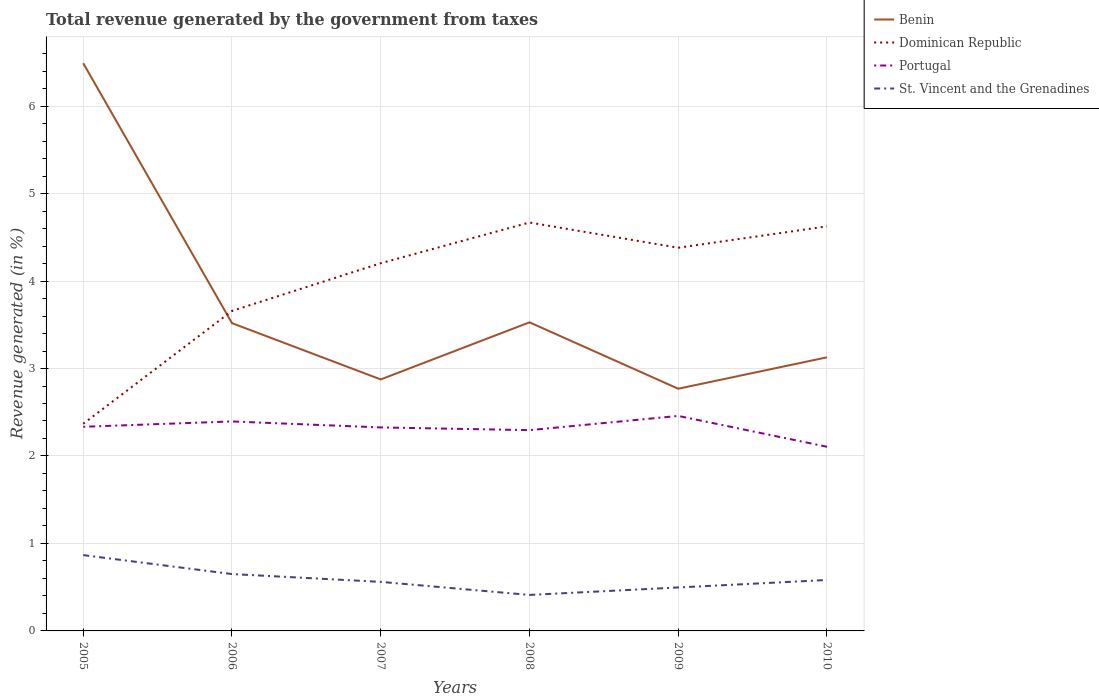How many different coloured lines are there?
Your response must be concise. 4. Does the line corresponding to St. Vincent and the Grenadines intersect with the line corresponding to Dominican Republic?
Make the answer very short. No. Across all years, what is the maximum total revenue generated in St. Vincent and the Grenadines?
Keep it short and to the point. 0.41. What is the total total revenue generated in Dominican Republic in the graph?
Give a very brief answer. 0.04. What is the difference between the highest and the second highest total revenue generated in Portugal?
Your response must be concise. 0.35. Is the total revenue generated in St. Vincent and the Grenadines strictly greater than the total revenue generated in Benin over the years?
Give a very brief answer. Yes. How many lines are there?
Provide a short and direct response. 4. What is the difference between two consecutive major ticks on the Y-axis?
Keep it short and to the point. 1. Does the graph contain any zero values?
Your answer should be compact. No. Does the graph contain grids?
Ensure brevity in your answer.  Yes. Where does the legend appear in the graph?
Make the answer very short. Top right. How are the legend labels stacked?
Provide a succinct answer. Vertical. What is the title of the graph?
Provide a short and direct response. Total revenue generated by the government from taxes. What is the label or title of the Y-axis?
Provide a succinct answer. Revenue generated (in %). What is the Revenue generated (in %) of Benin in 2005?
Your answer should be very brief. 6.49. What is the Revenue generated (in %) in Dominican Republic in 2005?
Your response must be concise. 2.37. What is the Revenue generated (in %) of Portugal in 2005?
Ensure brevity in your answer.  2.33. What is the Revenue generated (in %) in St. Vincent and the Grenadines in 2005?
Your response must be concise. 0.87. What is the Revenue generated (in %) in Benin in 2006?
Provide a succinct answer. 3.52. What is the Revenue generated (in %) in Dominican Republic in 2006?
Keep it short and to the point. 3.66. What is the Revenue generated (in %) of Portugal in 2006?
Your answer should be compact. 2.39. What is the Revenue generated (in %) of St. Vincent and the Grenadines in 2006?
Offer a very short reply. 0.65. What is the Revenue generated (in %) of Benin in 2007?
Keep it short and to the point. 2.88. What is the Revenue generated (in %) of Dominican Republic in 2007?
Your answer should be very brief. 4.2. What is the Revenue generated (in %) of Portugal in 2007?
Provide a short and direct response. 2.33. What is the Revenue generated (in %) of St. Vincent and the Grenadines in 2007?
Your answer should be compact. 0.56. What is the Revenue generated (in %) of Benin in 2008?
Your response must be concise. 3.53. What is the Revenue generated (in %) in Dominican Republic in 2008?
Keep it short and to the point. 4.67. What is the Revenue generated (in %) of Portugal in 2008?
Keep it short and to the point. 2.3. What is the Revenue generated (in %) of St. Vincent and the Grenadines in 2008?
Give a very brief answer. 0.41. What is the Revenue generated (in %) of Benin in 2009?
Give a very brief answer. 2.77. What is the Revenue generated (in %) in Dominican Republic in 2009?
Provide a succinct answer. 4.38. What is the Revenue generated (in %) of Portugal in 2009?
Make the answer very short. 2.46. What is the Revenue generated (in %) of St. Vincent and the Grenadines in 2009?
Provide a succinct answer. 0.5. What is the Revenue generated (in %) in Benin in 2010?
Give a very brief answer. 3.13. What is the Revenue generated (in %) of Dominican Republic in 2010?
Keep it short and to the point. 4.63. What is the Revenue generated (in %) in Portugal in 2010?
Give a very brief answer. 2.11. What is the Revenue generated (in %) of St. Vincent and the Grenadines in 2010?
Offer a very short reply. 0.58. Across all years, what is the maximum Revenue generated (in %) in Benin?
Your response must be concise. 6.49. Across all years, what is the maximum Revenue generated (in %) of Dominican Republic?
Make the answer very short. 4.67. Across all years, what is the maximum Revenue generated (in %) in Portugal?
Your response must be concise. 2.46. Across all years, what is the maximum Revenue generated (in %) of St. Vincent and the Grenadines?
Ensure brevity in your answer.  0.87. Across all years, what is the minimum Revenue generated (in %) in Benin?
Offer a terse response. 2.77. Across all years, what is the minimum Revenue generated (in %) in Dominican Republic?
Give a very brief answer. 2.37. Across all years, what is the minimum Revenue generated (in %) of Portugal?
Make the answer very short. 2.11. Across all years, what is the minimum Revenue generated (in %) in St. Vincent and the Grenadines?
Give a very brief answer. 0.41. What is the total Revenue generated (in %) in Benin in the graph?
Your response must be concise. 22.31. What is the total Revenue generated (in %) in Dominican Republic in the graph?
Ensure brevity in your answer.  23.91. What is the total Revenue generated (in %) in Portugal in the graph?
Your answer should be compact. 13.91. What is the total Revenue generated (in %) in St. Vincent and the Grenadines in the graph?
Provide a short and direct response. 3.57. What is the difference between the Revenue generated (in %) in Benin in 2005 and that in 2006?
Keep it short and to the point. 2.97. What is the difference between the Revenue generated (in %) of Dominican Republic in 2005 and that in 2006?
Ensure brevity in your answer.  -1.29. What is the difference between the Revenue generated (in %) in Portugal in 2005 and that in 2006?
Make the answer very short. -0.06. What is the difference between the Revenue generated (in %) of St. Vincent and the Grenadines in 2005 and that in 2006?
Offer a terse response. 0.22. What is the difference between the Revenue generated (in %) of Benin in 2005 and that in 2007?
Make the answer very short. 3.62. What is the difference between the Revenue generated (in %) of Dominican Republic in 2005 and that in 2007?
Ensure brevity in your answer.  -1.84. What is the difference between the Revenue generated (in %) in Portugal in 2005 and that in 2007?
Ensure brevity in your answer.  0.01. What is the difference between the Revenue generated (in %) of St. Vincent and the Grenadines in 2005 and that in 2007?
Your response must be concise. 0.31. What is the difference between the Revenue generated (in %) of Benin in 2005 and that in 2008?
Provide a succinct answer. 2.96. What is the difference between the Revenue generated (in %) in Dominican Republic in 2005 and that in 2008?
Make the answer very short. -2.3. What is the difference between the Revenue generated (in %) in Portugal in 2005 and that in 2008?
Your answer should be compact. 0.04. What is the difference between the Revenue generated (in %) in St. Vincent and the Grenadines in 2005 and that in 2008?
Your answer should be very brief. 0.46. What is the difference between the Revenue generated (in %) in Benin in 2005 and that in 2009?
Keep it short and to the point. 3.72. What is the difference between the Revenue generated (in %) in Dominican Republic in 2005 and that in 2009?
Provide a short and direct response. -2.01. What is the difference between the Revenue generated (in %) of Portugal in 2005 and that in 2009?
Offer a very short reply. -0.12. What is the difference between the Revenue generated (in %) in St. Vincent and the Grenadines in 2005 and that in 2009?
Make the answer very short. 0.37. What is the difference between the Revenue generated (in %) in Benin in 2005 and that in 2010?
Provide a short and direct response. 3.36. What is the difference between the Revenue generated (in %) of Dominican Republic in 2005 and that in 2010?
Keep it short and to the point. -2.26. What is the difference between the Revenue generated (in %) in Portugal in 2005 and that in 2010?
Provide a succinct answer. 0.23. What is the difference between the Revenue generated (in %) of St. Vincent and the Grenadines in 2005 and that in 2010?
Provide a succinct answer. 0.28. What is the difference between the Revenue generated (in %) in Benin in 2006 and that in 2007?
Give a very brief answer. 0.64. What is the difference between the Revenue generated (in %) of Dominican Republic in 2006 and that in 2007?
Keep it short and to the point. -0.55. What is the difference between the Revenue generated (in %) in Portugal in 2006 and that in 2007?
Give a very brief answer. 0.07. What is the difference between the Revenue generated (in %) in St. Vincent and the Grenadines in 2006 and that in 2007?
Your answer should be very brief. 0.09. What is the difference between the Revenue generated (in %) of Benin in 2006 and that in 2008?
Your response must be concise. -0.01. What is the difference between the Revenue generated (in %) of Dominican Republic in 2006 and that in 2008?
Give a very brief answer. -1.01. What is the difference between the Revenue generated (in %) in Portugal in 2006 and that in 2008?
Make the answer very short. 0.1. What is the difference between the Revenue generated (in %) of St. Vincent and the Grenadines in 2006 and that in 2008?
Your answer should be very brief. 0.24. What is the difference between the Revenue generated (in %) of Dominican Republic in 2006 and that in 2009?
Provide a short and direct response. -0.72. What is the difference between the Revenue generated (in %) in Portugal in 2006 and that in 2009?
Give a very brief answer. -0.06. What is the difference between the Revenue generated (in %) in St. Vincent and the Grenadines in 2006 and that in 2009?
Give a very brief answer. 0.15. What is the difference between the Revenue generated (in %) in Benin in 2006 and that in 2010?
Give a very brief answer. 0.39. What is the difference between the Revenue generated (in %) in Dominican Republic in 2006 and that in 2010?
Offer a very short reply. -0.97. What is the difference between the Revenue generated (in %) of Portugal in 2006 and that in 2010?
Offer a terse response. 0.29. What is the difference between the Revenue generated (in %) of St. Vincent and the Grenadines in 2006 and that in 2010?
Your response must be concise. 0.07. What is the difference between the Revenue generated (in %) in Benin in 2007 and that in 2008?
Give a very brief answer. -0.65. What is the difference between the Revenue generated (in %) in Dominican Republic in 2007 and that in 2008?
Keep it short and to the point. -0.47. What is the difference between the Revenue generated (in %) of Portugal in 2007 and that in 2008?
Provide a short and direct response. 0.03. What is the difference between the Revenue generated (in %) of St. Vincent and the Grenadines in 2007 and that in 2008?
Give a very brief answer. 0.15. What is the difference between the Revenue generated (in %) in Benin in 2007 and that in 2009?
Make the answer very short. 0.11. What is the difference between the Revenue generated (in %) in Dominican Republic in 2007 and that in 2009?
Provide a short and direct response. -0.18. What is the difference between the Revenue generated (in %) of Portugal in 2007 and that in 2009?
Give a very brief answer. -0.13. What is the difference between the Revenue generated (in %) in St. Vincent and the Grenadines in 2007 and that in 2009?
Ensure brevity in your answer.  0.06. What is the difference between the Revenue generated (in %) of Benin in 2007 and that in 2010?
Offer a very short reply. -0.25. What is the difference between the Revenue generated (in %) of Dominican Republic in 2007 and that in 2010?
Your answer should be very brief. -0.42. What is the difference between the Revenue generated (in %) in Portugal in 2007 and that in 2010?
Provide a succinct answer. 0.22. What is the difference between the Revenue generated (in %) of St. Vincent and the Grenadines in 2007 and that in 2010?
Make the answer very short. -0.02. What is the difference between the Revenue generated (in %) of Benin in 2008 and that in 2009?
Provide a succinct answer. 0.76. What is the difference between the Revenue generated (in %) of Dominican Republic in 2008 and that in 2009?
Offer a very short reply. 0.29. What is the difference between the Revenue generated (in %) in Portugal in 2008 and that in 2009?
Provide a short and direct response. -0.16. What is the difference between the Revenue generated (in %) in St. Vincent and the Grenadines in 2008 and that in 2009?
Provide a short and direct response. -0.09. What is the difference between the Revenue generated (in %) of Benin in 2008 and that in 2010?
Keep it short and to the point. 0.4. What is the difference between the Revenue generated (in %) of Dominican Republic in 2008 and that in 2010?
Provide a succinct answer. 0.04. What is the difference between the Revenue generated (in %) in Portugal in 2008 and that in 2010?
Provide a succinct answer. 0.19. What is the difference between the Revenue generated (in %) in St. Vincent and the Grenadines in 2008 and that in 2010?
Offer a terse response. -0.17. What is the difference between the Revenue generated (in %) in Benin in 2009 and that in 2010?
Provide a succinct answer. -0.36. What is the difference between the Revenue generated (in %) of Dominican Republic in 2009 and that in 2010?
Provide a short and direct response. -0.24. What is the difference between the Revenue generated (in %) of Portugal in 2009 and that in 2010?
Offer a terse response. 0.35. What is the difference between the Revenue generated (in %) of St. Vincent and the Grenadines in 2009 and that in 2010?
Your answer should be very brief. -0.09. What is the difference between the Revenue generated (in %) of Benin in 2005 and the Revenue generated (in %) of Dominican Republic in 2006?
Keep it short and to the point. 2.83. What is the difference between the Revenue generated (in %) in Benin in 2005 and the Revenue generated (in %) in Portugal in 2006?
Ensure brevity in your answer.  4.1. What is the difference between the Revenue generated (in %) of Benin in 2005 and the Revenue generated (in %) of St. Vincent and the Grenadines in 2006?
Keep it short and to the point. 5.84. What is the difference between the Revenue generated (in %) of Dominican Republic in 2005 and the Revenue generated (in %) of Portugal in 2006?
Provide a short and direct response. -0.03. What is the difference between the Revenue generated (in %) in Dominican Republic in 2005 and the Revenue generated (in %) in St. Vincent and the Grenadines in 2006?
Your answer should be very brief. 1.72. What is the difference between the Revenue generated (in %) in Portugal in 2005 and the Revenue generated (in %) in St. Vincent and the Grenadines in 2006?
Offer a very short reply. 1.68. What is the difference between the Revenue generated (in %) in Benin in 2005 and the Revenue generated (in %) in Dominican Republic in 2007?
Provide a short and direct response. 2.29. What is the difference between the Revenue generated (in %) in Benin in 2005 and the Revenue generated (in %) in Portugal in 2007?
Your answer should be very brief. 4.16. What is the difference between the Revenue generated (in %) of Benin in 2005 and the Revenue generated (in %) of St. Vincent and the Grenadines in 2007?
Give a very brief answer. 5.93. What is the difference between the Revenue generated (in %) in Dominican Republic in 2005 and the Revenue generated (in %) in Portugal in 2007?
Your response must be concise. 0.04. What is the difference between the Revenue generated (in %) of Dominican Republic in 2005 and the Revenue generated (in %) of St. Vincent and the Grenadines in 2007?
Ensure brevity in your answer.  1.81. What is the difference between the Revenue generated (in %) of Portugal in 2005 and the Revenue generated (in %) of St. Vincent and the Grenadines in 2007?
Offer a very short reply. 1.77. What is the difference between the Revenue generated (in %) in Benin in 2005 and the Revenue generated (in %) in Dominican Republic in 2008?
Provide a short and direct response. 1.82. What is the difference between the Revenue generated (in %) in Benin in 2005 and the Revenue generated (in %) in Portugal in 2008?
Your response must be concise. 4.2. What is the difference between the Revenue generated (in %) of Benin in 2005 and the Revenue generated (in %) of St. Vincent and the Grenadines in 2008?
Provide a short and direct response. 6.08. What is the difference between the Revenue generated (in %) of Dominican Republic in 2005 and the Revenue generated (in %) of Portugal in 2008?
Your response must be concise. 0.07. What is the difference between the Revenue generated (in %) in Dominican Republic in 2005 and the Revenue generated (in %) in St. Vincent and the Grenadines in 2008?
Give a very brief answer. 1.96. What is the difference between the Revenue generated (in %) in Portugal in 2005 and the Revenue generated (in %) in St. Vincent and the Grenadines in 2008?
Make the answer very short. 1.92. What is the difference between the Revenue generated (in %) in Benin in 2005 and the Revenue generated (in %) in Dominican Republic in 2009?
Your answer should be very brief. 2.11. What is the difference between the Revenue generated (in %) of Benin in 2005 and the Revenue generated (in %) of Portugal in 2009?
Make the answer very short. 4.03. What is the difference between the Revenue generated (in %) of Benin in 2005 and the Revenue generated (in %) of St. Vincent and the Grenadines in 2009?
Your answer should be very brief. 5.99. What is the difference between the Revenue generated (in %) of Dominican Republic in 2005 and the Revenue generated (in %) of Portugal in 2009?
Give a very brief answer. -0.09. What is the difference between the Revenue generated (in %) of Dominican Republic in 2005 and the Revenue generated (in %) of St. Vincent and the Grenadines in 2009?
Provide a short and direct response. 1.87. What is the difference between the Revenue generated (in %) in Portugal in 2005 and the Revenue generated (in %) in St. Vincent and the Grenadines in 2009?
Ensure brevity in your answer.  1.84. What is the difference between the Revenue generated (in %) of Benin in 2005 and the Revenue generated (in %) of Dominican Republic in 2010?
Offer a very short reply. 1.87. What is the difference between the Revenue generated (in %) of Benin in 2005 and the Revenue generated (in %) of Portugal in 2010?
Provide a succinct answer. 4.39. What is the difference between the Revenue generated (in %) in Benin in 2005 and the Revenue generated (in %) in St. Vincent and the Grenadines in 2010?
Give a very brief answer. 5.91. What is the difference between the Revenue generated (in %) of Dominican Republic in 2005 and the Revenue generated (in %) of Portugal in 2010?
Provide a short and direct response. 0.26. What is the difference between the Revenue generated (in %) in Dominican Republic in 2005 and the Revenue generated (in %) in St. Vincent and the Grenadines in 2010?
Provide a succinct answer. 1.79. What is the difference between the Revenue generated (in %) in Portugal in 2005 and the Revenue generated (in %) in St. Vincent and the Grenadines in 2010?
Offer a very short reply. 1.75. What is the difference between the Revenue generated (in %) of Benin in 2006 and the Revenue generated (in %) of Dominican Republic in 2007?
Keep it short and to the point. -0.68. What is the difference between the Revenue generated (in %) in Benin in 2006 and the Revenue generated (in %) in Portugal in 2007?
Your response must be concise. 1.19. What is the difference between the Revenue generated (in %) in Benin in 2006 and the Revenue generated (in %) in St. Vincent and the Grenadines in 2007?
Your response must be concise. 2.96. What is the difference between the Revenue generated (in %) in Dominican Republic in 2006 and the Revenue generated (in %) in Portugal in 2007?
Make the answer very short. 1.33. What is the difference between the Revenue generated (in %) of Dominican Republic in 2006 and the Revenue generated (in %) of St. Vincent and the Grenadines in 2007?
Keep it short and to the point. 3.1. What is the difference between the Revenue generated (in %) of Portugal in 2006 and the Revenue generated (in %) of St. Vincent and the Grenadines in 2007?
Your answer should be very brief. 1.83. What is the difference between the Revenue generated (in %) of Benin in 2006 and the Revenue generated (in %) of Dominican Republic in 2008?
Offer a terse response. -1.15. What is the difference between the Revenue generated (in %) of Benin in 2006 and the Revenue generated (in %) of Portugal in 2008?
Make the answer very short. 1.22. What is the difference between the Revenue generated (in %) of Benin in 2006 and the Revenue generated (in %) of St. Vincent and the Grenadines in 2008?
Your answer should be compact. 3.11. What is the difference between the Revenue generated (in %) in Dominican Republic in 2006 and the Revenue generated (in %) in Portugal in 2008?
Your response must be concise. 1.36. What is the difference between the Revenue generated (in %) of Dominican Republic in 2006 and the Revenue generated (in %) of St. Vincent and the Grenadines in 2008?
Your response must be concise. 3.25. What is the difference between the Revenue generated (in %) of Portugal in 2006 and the Revenue generated (in %) of St. Vincent and the Grenadines in 2008?
Provide a succinct answer. 1.98. What is the difference between the Revenue generated (in %) in Benin in 2006 and the Revenue generated (in %) in Dominican Republic in 2009?
Provide a succinct answer. -0.86. What is the difference between the Revenue generated (in %) of Benin in 2006 and the Revenue generated (in %) of Portugal in 2009?
Offer a terse response. 1.06. What is the difference between the Revenue generated (in %) of Benin in 2006 and the Revenue generated (in %) of St. Vincent and the Grenadines in 2009?
Your answer should be very brief. 3.02. What is the difference between the Revenue generated (in %) in Dominican Republic in 2006 and the Revenue generated (in %) in Portugal in 2009?
Ensure brevity in your answer.  1.2. What is the difference between the Revenue generated (in %) of Dominican Republic in 2006 and the Revenue generated (in %) of St. Vincent and the Grenadines in 2009?
Offer a very short reply. 3.16. What is the difference between the Revenue generated (in %) of Portugal in 2006 and the Revenue generated (in %) of St. Vincent and the Grenadines in 2009?
Offer a terse response. 1.9. What is the difference between the Revenue generated (in %) of Benin in 2006 and the Revenue generated (in %) of Dominican Republic in 2010?
Keep it short and to the point. -1.11. What is the difference between the Revenue generated (in %) in Benin in 2006 and the Revenue generated (in %) in Portugal in 2010?
Offer a very short reply. 1.41. What is the difference between the Revenue generated (in %) in Benin in 2006 and the Revenue generated (in %) in St. Vincent and the Grenadines in 2010?
Offer a terse response. 2.94. What is the difference between the Revenue generated (in %) of Dominican Republic in 2006 and the Revenue generated (in %) of Portugal in 2010?
Give a very brief answer. 1.55. What is the difference between the Revenue generated (in %) of Dominican Republic in 2006 and the Revenue generated (in %) of St. Vincent and the Grenadines in 2010?
Provide a short and direct response. 3.08. What is the difference between the Revenue generated (in %) of Portugal in 2006 and the Revenue generated (in %) of St. Vincent and the Grenadines in 2010?
Your answer should be compact. 1.81. What is the difference between the Revenue generated (in %) in Benin in 2007 and the Revenue generated (in %) in Dominican Republic in 2008?
Keep it short and to the point. -1.79. What is the difference between the Revenue generated (in %) of Benin in 2007 and the Revenue generated (in %) of Portugal in 2008?
Provide a succinct answer. 0.58. What is the difference between the Revenue generated (in %) of Benin in 2007 and the Revenue generated (in %) of St. Vincent and the Grenadines in 2008?
Offer a very short reply. 2.46. What is the difference between the Revenue generated (in %) in Dominican Republic in 2007 and the Revenue generated (in %) in Portugal in 2008?
Your response must be concise. 1.91. What is the difference between the Revenue generated (in %) in Dominican Republic in 2007 and the Revenue generated (in %) in St. Vincent and the Grenadines in 2008?
Give a very brief answer. 3.79. What is the difference between the Revenue generated (in %) of Portugal in 2007 and the Revenue generated (in %) of St. Vincent and the Grenadines in 2008?
Provide a succinct answer. 1.92. What is the difference between the Revenue generated (in %) in Benin in 2007 and the Revenue generated (in %) in Dominican Republic in 2009?
Your answer should be compact. -1.51. What is the difference between the Revenue generated (in %) in Benin in 2007 and the Revenue generated (in %) in Portugal in 2009?
Your answer should be compact. 0.42. What is the difference between the Revenue generated (in %) in Benin in 2007 and the Revenue generated (in %) in St. Vincent and the Grenadines in 2009?
Offer a very short reply. 2.38. What is the difference between the Revenue generated (in %) of Dominican Republic in 2007 and the Revenue generated (in %) of Portugal in 2009?
Give a very brief answer. 1.75. What is the difference between the Revenue generated (in %) in Dominican Republic in 2007 and the Revenue generated (in %) in St. Vincent and the Grenadines in 2009?
Offer a terse response. 3.71. What is the difference between the Revenue generated (in %) of Portugal in 2007 and the Revenue generated (in %) of St. Vincent and the Grenadines in 2009?
Your answer should be very brief. 1.83. What is the difference between the Revenue generated (in %) of Benin in 2007 and the Revenue generated (in %) of Dominican Republic in 2010?
Keep it short and to the point. -1.75. What is the difference between the Revenue generated (in %) in Benin in 2007 and the Revenue generated (in %) in Portugal in 2010?
Ensure brevity in your answer.  0.77. What is the difference between the Revenue generated (in %) of Benin in 2007 and the Revenue generated (in %) of St. Vincent and the Grenadines in 2010?
Your response must be concise. 2.29. What is the difference between the Revenue generated (in %) in Dominican Republic in 2007 and the Revenue generated (in %) in Portugal in 2010?
Your answer should be compact. 2.1. What is the difference between the Revenue generated (in %) of Dominican Republic in 2007 and the Revenue generated (in %) of St. Vincent and the Grenadines in 2010?
Give a very brief answer. 3.62. What is the difference between the Revenue generated (in %) of Portugal in 2007 and the Revenue generated (in %) of St. Vincent and the Grenadines in 2010?
Provide a short and direct response. 1.74. What is the difference between the Revenue generated (in %) in Benin in 2008 and the Revenue generated (in %) in Dominican Republic in 2009?
Offer a terse response. -0.85. What is the difference between the Revenue generated (in %) of Benin in 2008 and the Revenue generated (in %) of Portugal in 2009?
Give a very brief answer. 1.07. What is the difference between the Revenue generated (in %) in Benin in 2008 and the Revenue generated (in %) in St. Vincent and the Grenadines in 2009?
Offer a terse response. 3.03. What is the difference between the Revenue generated (in %) in Dominican Republic in 2008 and the Revenue generated (in %) in Portugal in 2009?
Provide a succinct answer. 2.21. What is the difference between the Revenue generated (in %) of Dominican Republic in 2008 and the Revenue generated (in %) of St. Vincent and the Grenadines in 2009?
Provide a succinct answer. 4.17. What is the difference between the Revenue generated (in %) in Portugal in 2008 and the Revenue generated (in %) in St. Vincent and the Grenadines in 2009?
Your answer should be compact. 1.8. What is the difference between the Revenue generated (in %) in Benin in 2008 and the Revenue generated (in %) in Dominican Republic in 2010?
Give a very brief answer. -1.1. What is the difference between the Revenue generated (in %) in Benin in 2008 and the Revenue generated (in %) in Portugal in 2010?
Offer a very short reply. 1.42. What is the difference between the Revenue generated (in %) of Benin in 2008 and the Revenue generated (in %) of St. Vincent and the Grenadines in 2010?
Your answer should be compact. 2.95. What is the difference between the Revenue generated (in %) of Dominican Republic in 2008 and the Revenue generated (in %) of Portugal in 2010?
Offer a terse response. 2.56. What is the difference between the Revenue generated (in %) in Dominican Republic in 2008 and the Revenue generated (in %) in St. Vincent and the Grenadines in 2010?
Provide a short and direct response. 4.09. What is the difference between the Revenue generated (in %) in Portugal in 2008 and the Revenue generated (in %) in St. Vincent and the Grenadines in 2010?
Give a very brief answer. 1.71. What is the difference between the Revenue generated (in %) in Benin in 2009 and the Revenue generated (in %) in Dominican Republic in 2010?
Provide a short and direct response. -1.86. What is the difference between the Revenue generated (in %) in Benin in 2009 and the Revenue generated (in %) in Portugal in 2010?
Make the answer very short. 0.66. What is the difference between the Revenue generated (in %) of Benin in 2009 and the Revenue generated (in %) of St. Vincent and the Grenadines in 2010?
Ensure brevity in your answer.  2.19. What is the difference between the Revenue generated (in %) of Dominican Republic in 2009 and the Revenue generated (in %) of Portugal in 2010?
Keep it short and to the point. 2.28. What is the difference between the Revenue generated (in %) in Dominican Republic in 2009 and the Revenue generated (in %) in St. Vincent and the Grenadines in 2010?
Your answer should be compact. 3.8. What is the difference between the Revenue generated (in %) in Portugal in 2009 and the Revenue generated (in %) in St. Vincent and the Grenadines in 2010?
Your response must be concise. 1.88. What is the average Revenue generated (in %) in Benin per year?
Make the answer very short. 3.72. What is the average Revenue generated (in %) in Dominican Republic per year?
Your answer should be very brief. 3.98. What is the average Revenue generated (in %) of Portugal per year?
Offer a very short reply. 2.32. What is the average Revenue generated (in %) in St. Vincent and the Grenadines per year?
Offer a terse response. 0.59. In the year 2005, what is the difference between the Revenue generated (in %) in Benin and Revenue generated (in %) in Dominican Republic?
Your answer should be compact. 4.12. In the year 2005, what is the difference between the Revenue generated (in %) of Benin and Revenue generated (in %) of Portugal?
Keep it short and to the point. 4.16. In the year 2005, what is the difference between the Revenue generated (in %) in Benin and Revenue generated (in %) in St. Vincent and the Grenadines?
Offer a very short reply. 5.62. In the year 2005, what is the difference between the Revenue generated (in %) of Dominican Republic and Revenue generated (in %) of Portugal?
Give a very brief answer. 0.03. In the year 2005, what is the difference between the Revenue generated (in %) in Dominican Republic and Revenue generated (in %) in St. Vincent and the Grenadines?
Your answer should be very brief. 1.5. In the year 2005, what is the difference between the Revenue generated (in %) of Portugal and Revenue generated (in %) of St. Vincent and the Grenadines?
Keep it short and to the point. 1.47. In the year 2006, what is the difference between the Revenue generated (in %) of Benin and Revenue generated (in %) of Dominican Republic?
Give a very brief answer. -0.14. In the year 2006, what is the difference between the Revenue generated (in %) in Benin and Revenue generated (in %) in Portugal?
Your answer should be very brief. 1.12. In the year 2006, what is the difference between the Revenue generated (in %) in Benin and Revenue generated (in %) in St. Vincent and the Grenadines?
Keep it short and to the point. 2.87. In the year 2006, what is the difference between the Revenue generated (in %) of Dominican Republic and Revenue generated (in %) of Portugal?
Your response must be concise. 1.26. In the year 2006, what is the difference between the Revenue generated (in %) of Dominican Republic and Revenue generated (in %) of St. Vincent and the Grenadines?
Provide a succinct answer. 3.01. In the year 2006, what is the difference between the Revenue generated (in %) of Portugal and Revenue generated (in %) of St. Vincent and the Grenadines?
Provide a succinct answer. 1.74. In the year 2007, what is the difference between the Revenue generated (in %) in Benin and Revenue generated (in %) in Dominican Republic?
Give a very brief answer. -1.33. In the year 2007, what is the difference between the Revenue generated (in %) in Benin and Revenue generated (in %) in Portugal?
Offer a terse response. 0.55. In the year 2007, what is the difference between the Revenue generated (in %) of Benin and Revenue generated (in %) of St. Vincent and the Grenadines?
Keep it short and to the point. 2.31. In the year 2007, what is the difference between the Revenue generated (in %) of Dominican Republic and Revenue generated (in %) of Portugal?
Make the answer very short. 1.88. In the year 2007, what is the difference between the Revenue generated (in %) of Dominican Republic and Revenue generated (in %) of St. Vincent and the Grenadines?
Keep it short and to the point. 3.64. In the year 2007, what is the difference between the Revenue generated (in %) in Portugal and Revenue generated (in %) in St. Vincent and the Grenadines?
Offer a terse response. 1.77. In the year 2008, what is the difference between the Revenue generated (in %) in Benin and Revenue generated (in %) in Dominican Republic?
Your response must be concise. -1.14. In the year 2008, what is the difference between the Revenue generated (in %) in Benin and Revenue generated (in %) in Portugal?
Keep it short and to the point. 1.23. In the year 2008, what is the difference between the Revenue generated (in %) in Benin and Revenue generated (in %) in St. Vincent and the Grenadines?
Offer a terse response. 3.12. In the year 2008, what is the difference between the Revenue generated (in %) of Dominican Republic and Revenue generated (in %) of Portugal?
Ensure brevity in your answer.  2.37. In the year 2008, what is the difference between the Revenue generated (in %) of Dominican Republic and Revenue generated (in %) of St. Vincent and the Grenadines?
Give a very brief answer. 4.26. In the year 2008, what is the difference between the Revenue generated (in %) of Portugal and Revenue generated (in %) of St. Vincent and the Grenadines?
Your answer should be compact. 1.88. In the year 2009, what is the difference between the Revenue generated (in %) of Benin and Revenue generated (in %) of Dominican Republic?
Provide a succinct answer. -1.61. In the year 2009, what is the difference between the Revenue generated (in %) in Benin and Revenue generated (in %) in Portugal?
Make the answer very short. 0.31. In the year 2009, what is the difference between the Revenue generated (in %) of Benin and Revenue generated (in %) of St. Vincent and the Grenadines?
Offer a terse response. 2.27. In the year 2009, what is the difference between the Revenue generated (in %) of Dominican Republic and Revenue generated (in %) of Portugal?
Provide a succinct answer. 1.92. In the year 2009, what is the difference between the Revenue generated (in %) of Dominican Republic and Revenue generated (in %) of St. Vincent and the Grenadines?
Make the answer very short. 3.88. In the year 2009, what is the difference between the Revenue generated (in %) of Portugal and Revenue generated (in %) of St. Vincent and the Grenadines?
Give a very brief answer. 1.96. In the year 2010, what is the difference between the Revenue generated (in %) in Benin and Revenue generated (in %) in Dominican Republic?
Keep it short and to the point. -1.5. In the year 2010, what is the difference between the Revenue generated (in %) of Benin and Revenue generated (in %) of Portugal?
Offer a terse response. 1.02. In the year 2010, what is the difference between the Revenue generated (in %) of Benin and Revenue generated (in %) of St. Vincent and the Grenadines?
Provide a short and direct response. 2.55. In the year 2010, what is the difference between the Revenue generated (in %) of Dominican Republic and Revenue generated (in %) of Portugal?
Offer a very short reply. 2.52. In the year 2010, what is the difference between the Revenue generated (in %) in Dominican Republic and Revenue generated (in %) in St. Vincent and the Grenadines?
Offer a terse response. 4.04. In the year 2010, what is the difference between the Revenue generated (in %) in Portugal and Revenue generated (in %) in St. Vincent and the Grenadines?
Provide a succinct answer. 1.52. What is the ratio of the Revenue generated (in %) in Benin in 2005 to that in 2006?
Offer a very short reply. 1.84. What is the ratio of the Revenue generated (in %) in Dominican Republic in 2005 to that in 2006?
Your answer should be compact. 0.65. What is the ratio of the Revenue generated (in %) in Portugal in 2005 to that in 2006?
Your answer should be compact. 0.97. What is the ratio of the Revenue generated (in %) in St. Vincent and the Grenadines in 2005 to that in 2006?
Your response must be concise. 1.33. What is the ratio of the Revenue generated (in %) in Benin in 2005 to that in 2007?
Keep it short and to the point. 2.26. What is the ratio of the Revenue generated (in %) of Dominican Republic in 2005 to that in 2007?
Offer a terse response. 0.56. What is the ratio of the Revenue generated (in %) in Portugal in 2005 to that in 2007?
Ensure brevity in your answer.  1. What is the ratio of the Revenue generated (in %) in St. Vincent and the Grenadines in 2005 to that in 2007?
Offer a very short reply. 1.55. What is the ratio of the Revenue generated (in %) in Benin in 2005 to that in 2008?
Provide a succinct answer. 1.84. What is the ratio of the Revenue generated (in %) in Dominican Republic in 2005 to that in 2008?
Ensure brevity in your answer.  0.51. What is the ratio of the Revenue generated (in %) in Portugal in 2005 to that in 2008?
Give a very brief answer. 1.02. What is the ratio of the Revenue generated (in %) of St. Vincent and the Grenadines in 2005 to that in 2008?
Keep it short and to the point. 2.11. What is the ratio of the Revenue generated (in %) in Benin in 2005 to that in 2009?
Offer a very short reply. 2.34. What is the ratio of the Revenue generated (in %) in Dominican Republic in 2005 to that in 2009?
Offer a very short reply. 0.54. What is the ratio of the Revenue generated (in %) of Portugal in 2005 to that in 2009?
Ensure brevity in your answer.  0.95. What is the ratio of the Revenue generated (in %) of St. Vincent and the Grenadines in 2005 to that in 2009?
Your answer should be compact. 1.74. What is the ratio of the Revenue generated (in %) in Benin in 2005 to that in 2010?
Your answer should be compact. 2.08. What is the ratio of the Revenue generated (in %) in Dominican Republic in 2005 to that in 2010?
Your answer should be compact. 0.51. What is the ratio of the Revenue generated (in %) in Portugal in 2005 to that in 2010?
Give a very brief answer. 1.11. What is the ratio of the Revenue generated (in %) in St. Vincent and the Grenadines in 2005 to that in 2010?
Offer a terse response. 1.49. What is the ratio of the Revenue generated (in %) in Benin in 2006 to that in 2007?
Provide a short and direct response. 1.22. What is the ratio of the Revenue generated (in %) of Dominican Republic in 2006 to that in 2007?
Provide a short and direct response. 0.87. What is the ratio of the Revenue generated (in %) in Portugal in 2006 to that in 2007?
Give a very brief answer. 1.03. What is the ratio of the Revenue generated (in %) of St. Vincent and the Grenadines in 2006 to that in 2007?
Your answer should be very brief. 1.16. What is the ratio of the Revenue generated (in %) of Benin in 2006 to that in 2008?
Your answer should be very brief. 1. What is the ratio of the Revenue generated (in %) of Dominican Republic in 2006 to that in 2008?
Your answer should be very brief. 0.78. What is the ratio of the Revenue generated (in %) in Portugal in 2006 to that in 2008?
Your answer should be very brief. 1.04. What is the ratio of the Revenue generated (in %) in St. Vincent and the Grenadines in 2006 to that in 2008?
Your answer should be compact. 1.58. What is the ratio of the Revenue generated (in %) of Benin in 2006 to that in 2009?
Keep it short and to the point. 1.27. What is the ratio of the Revenue generated (in %) in Dominican Republic in 2006 to that in 2009?
Provide a short and direct response. 0.84. What is the ratio of the Revenue generated (in %) in Portugal in 2006 to that in 2009?
Keep it short and to the point. 0.97. What is the ratio of the Revenue generated (in %) in St. Vincent and the Grenadines in 2006 to that in 2009?
Give a very brief answer. 1.31. What is the ratio of the Revenue generated (in %) of Benin in 2006 to that in 2010?
Your answer should be very brief. 1.12. What is the ratio of the Revenue generated (in %) in Dominican Republic in 2006 to that in 2010?
Your response must be concise. 0.79. What is the ratio of the Revenue generated (in %) in Portugal in 2006 to that in 2010?
Offer a terse response. 1.14. What is the ratio of the Revenue generated (in %) in St. Vincent and the Grenadines in 2006 to that in 2010?
Offer a terse response. 1.12. What is the ratio of the Revenue generated (in %) of Benin in 2007 to that in 2008?
Offer a terse response. 0.81. What is the ratio of the Revenue generated (in %) in Dominican Republic in 2007 to that in 2008?
Your answer should be very brief. 0.9. What is the ratio of the Revenue generated (in %) of Portugal in 2007 to that in 2008?
Ensure brevity in your answer.  1.01. What is the ratio of the Revenue generated (in %) in St. Vincent and the Grenadines in 2007 to that in 2008?
Ensure brevity in your answer.  1.36. What is the ratio of the Revenue generated (in %) in Benin in 2007 to that in 2009?
Your answer should be very brief. 1.04. What is the ratio of the Revenue generated (in %) of Dominican Republic in 2007 to that in 2009?
Keep it short and to the point. 0.96. What is the ratio of the Revenue generated (in %) in Portugal in 2007 to that in 2009?
Provide a succinct answer. 0.95. What is the ratio of the Revenue generated (in %) of St. Vincent and the Grenadines in 2007 to that in 2009?
Your response must be concise. 1.13. What is the ratio of the Revenue generated (in %) in Benin in 2007 to that in 2010?
Offer a very short reply. 0.92. What is the ratio of the Revenue generated (in %) of Dominican Republic in 2007 to that in 2010?
Give a very brief answer. 0.91. What is the ratio of the Revenue generated (in %) of Portugal in 2007 to that in 2010?
Provide a succinct answer. 1.1. What is the ratio of the Revenue generated (in %) of St. Vincent and the Grenadines in 2007 to that in 2010?
Provide a short and direct response. 0.96. What is the ratio of the Revenue generated (in %) in Benin in 2008 to that in 2009?
Your answer should be compact. 1.27. What is the ratio of the Revenue generated (in %) in Dominican Republic in 2008 to that in 2009?
Provide a short and direct response. 1.07. What is the ratio of the Revenue generated (in %) of Portugal in 2008 to that in 2009?
Offer a very short reply. 0.93. What is the ratio of the Revenue generated (in %) of St. Vincent and the Grenadines in 2008 to that in 2009?
Offer a terse response. 0.83. What is the ratio of the Revenue generated (in %) of Benin in 2008 to that in 2010?
Your answer should be very brief. 1.13. What is the ratio of the Revenue generated (in %) of Dominican Republic in 2008 to that in 2010?
Ensure brevity in your answer.  1.01. What is the ratio of the Revenue generated (in %) in Portugal in 2008 to that in 2010?
Your answer should be very brief. 1.09. What is the ratio of the Revenue generated (in %) in St. Vincent and the Grenadines in 2008 to that in 2010?
Provide a succinct answer. 0.71. What is the ratio of the Revenue generated (in %) of Benin in 2009 to that in 2010?
Your response must be concise. 0.89. What is the ratio of the Revenue generated (in %) of Dominican Republic in 2009 to that in 2010?
Keep it short and to the point. 0.95. What is the ratio of the Revenue generated (in %) in Portugal in 2009 to that in 2010?
Your answer should be compact. 1.17. What is the ratio of the Revenue generated (in %) of St. Vincent and the Grenadines in 2009 to that in 2010?
Give a very brief answer. 0.85. What is the difference between the highest and the second highest Revenue generated (in %) of Benin?
Offer a very short reply. 2.96. What is the difference between the highest and the second highest Revenue generated (in %) in Dominican Republic?
Keep it short and to the point. 0.04. What is the difference between the highest and the second highest Revenue generated (in %) in Portugal?
Your answer should be very brief. 0.06. What is the difference between the highest and the second highest Revenue generated (in %) of St. Vincent and the Grenadines?
Your answer should be very brief. 0.22. What is the difference between the highest and the lowest Revenue generated (in %) in Benin?
Ensure brevity in your answer.  3.72. What is the difference between the highest and the lowest Revenue generated (in %) in Dominican Republic?
Offer a terse response. 2.3. What is the difference between the highest and the lowest Revenue generated (in %) in Portugal?
Provide a short and direct response. 0.35. What is the difference between the highest and the lowest Revenue generated (in %) in St. Vincent and the Grenadines?
Keep it short and to the point. 0.46. 